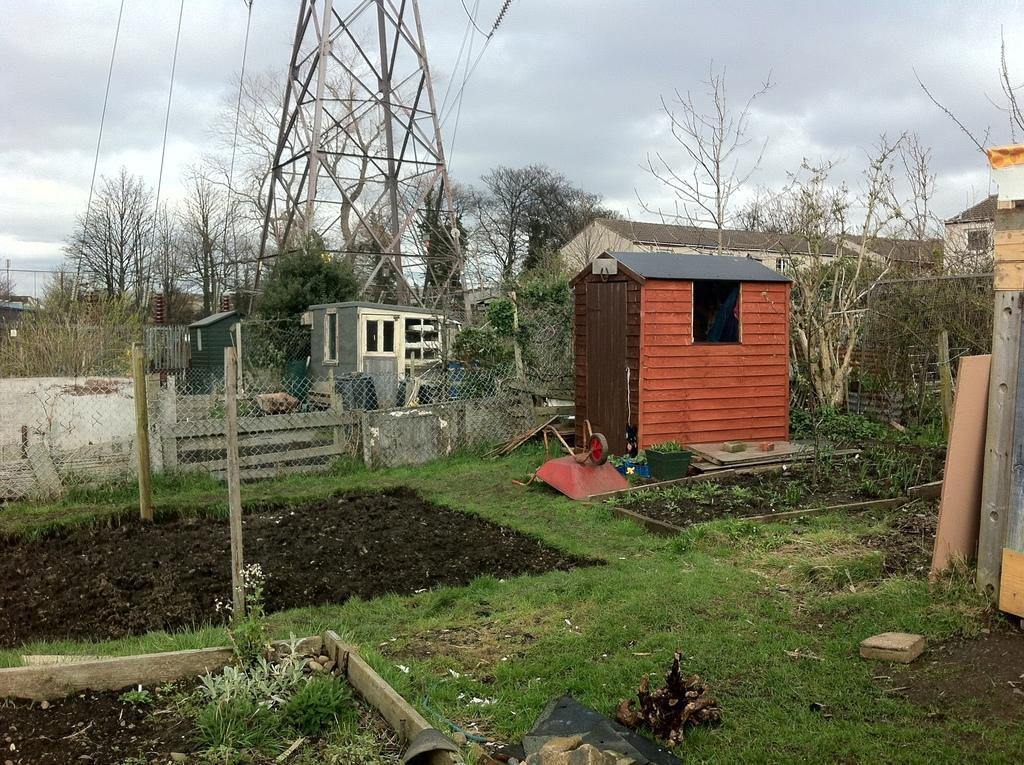Describe this image in one or two sentences. In the image we can see transmission tower and electric wires. We can even see there are trees, plants and grass. Here we can see the houses, mesh, poles and the cloudy sky. 